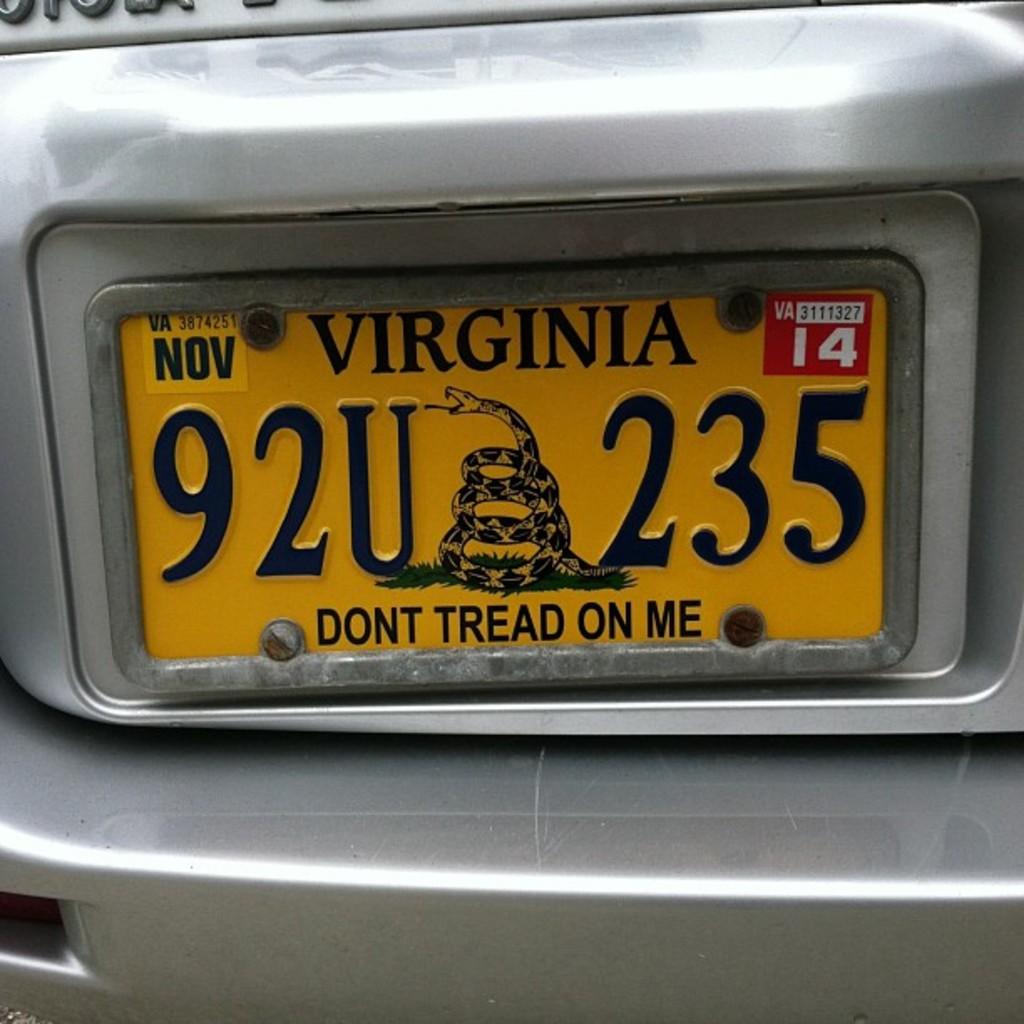What state is the license plate from?
Give a very brief answer. Virginia. What is the license plate number?
Provide a succinct answer. 92u 235. 